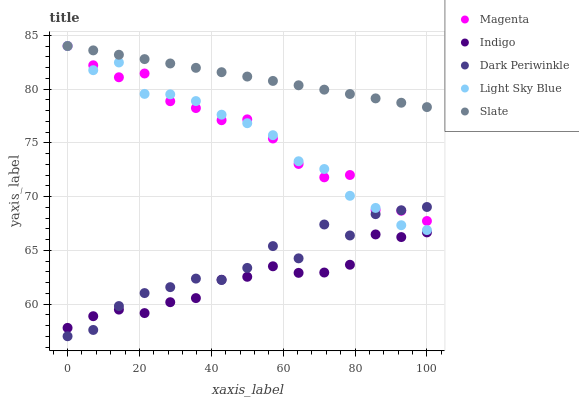Does Indigo have the minimum area under the curve?
Answer yes or no. Yes. Does Slate have the maximum area under the curve?
Answer yes or no. Yes. Does Magenta have the minimum area under the curve?
Answer yes or no. No. Does Magenta have the maximum area under the curve?
Answer yes or no. No. Is Slate the smoothest?
Answer yes or no. Yes. Is Dark Periwinkle the roughest?
Answer yes or no. Yes. Is Magenta the smoothest?
Answer yes or no. No. Is Magenta the roughest?
Answer yes or no. No. Does Dark Periwinkle have the lowest value?
Answer yes or no. Yes. Does Magenta have the lowest value?
Answer yes or no. No. Does Light Sky Blue have the highest value?
Answer yes or no. Yes. Does Indigo have the highest value?
Answer yes or no. No. Is Indigo less than Magenta?
Answer yes or no. Yes. Is Slate greater than Indigo?
Answer yes or no. Yes. Does Light Sky Blue intersect Slate?
Answer yes or no. Yes. Is Light Sky Blue less than Slate?
Answer yes or no. No. Is Light Sky Blue greater than Slate?
Answer yes or no. No. Does Indigo intersect Magenta?
Answer yes or no. No. 